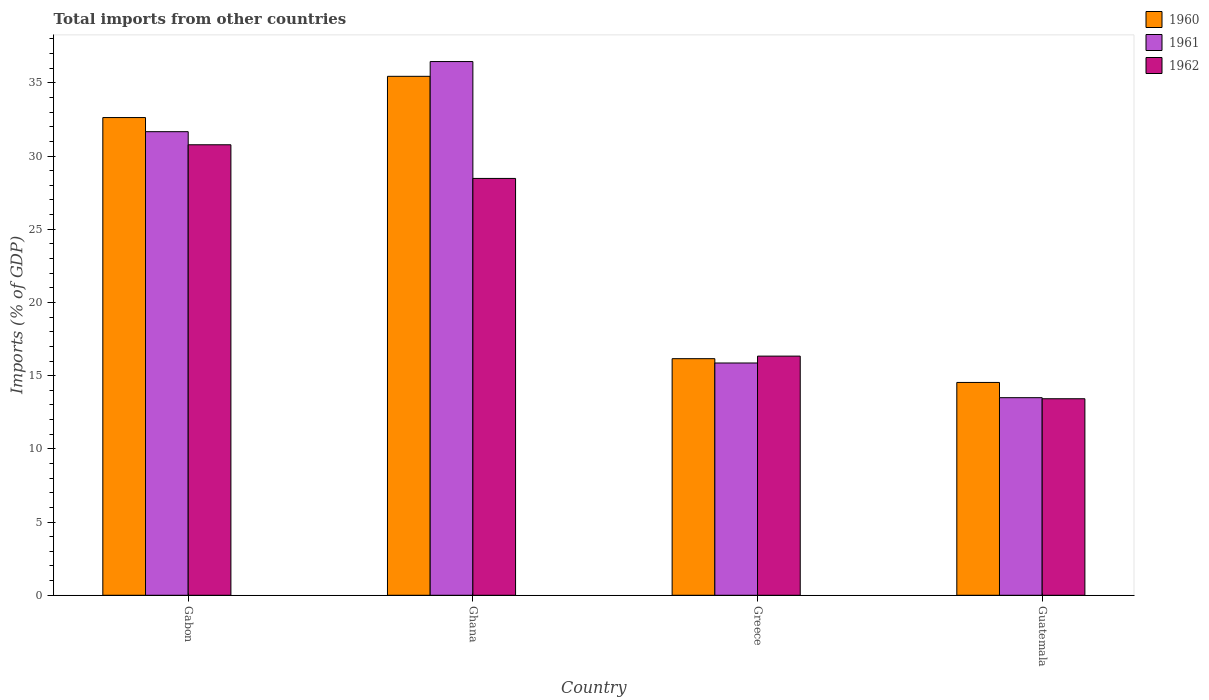How many different coloured bars are there?
Keep it short and to the point. 3. How many groups of bars are there?
Offer a terse response. 4. Are the number of bars per tick equal to the number of legend labels?
Provide a short and direct response. Yes. How many bars are there on the 3rd tick from the right?
Give a very brief answer. 3. What is the label of the 3rd group of bars from the left?
Your answer should be compact. Greece. What is the total imports in 1961 in Greece?
Ensure brevity in your answer.  15.86. Across all countries, what is the maximum total imports in 1961?
Provide a short and direct response. 36.45. Across all countries, what is the minimum total imports in 1960?
Your answer should be very brief. 14.54. In which country was the total imports in 1962 minimum?
Offer a very short reply. Guatemala. What is the total total imports in 1962 in the graph?
Give a very brief answer. 89. What is the difference between the total imports in 1961 in Ghana and that in Greece?
Provide a short and direct response. 20.59. What is the difference between the total imports in 1960 in Ghana and the total imports in 1961 in Gabon?
Provide a short and direct response. 3.78. What is the average total imports in 1960 per country?
Give a very brief answer. 24.69. What is the difference between the total imports of/in 1962 and total imports of/in 1960 in Greece?
Provide a succinct answer. 0.18. What is the ratio of the total imports in 1960 in Gabon to that in Greece?
Give a very brief answer. 2.02. Is the total imports in 1962 in Ghana less than that in Greece?
Make the answer very short. No. What is the difference between the highest and the second highest total imports in 1961?
Keep it short and to the point. -20.59. What is the difference between the highest and the lowest total imports in 1960?
Offer a terse response. 20.91. In how many countries, is the total imports in 1960 greater than the average total imports in 1960 taken over all countries?
Offer a very short reply. 2. What does the 2nd bar from the right in Greece represents?
Give a very brief answer. 1961. How many bars are there?
Offer a terse response. 12. How many countries are there in the graph?
Ensure brevity in your answer.  4. Does the graph contain any zero values?
Your response must be concise. No. Where does the legend appear in the graph?
Give a very brief answer. Top right. What is the title of the graph?
Your answer should be very brief. Total imports from other countries. Does "2012" appear as one of the legend labels in the graph?
Offer a very short reply. No. What is the label or title of the Y-axis?
Ensure brevity in your answer.  Imports (% of GDP). What is the Imports (% of GDP) in 1960 in Gabon?
Your answer should be very brief. 32.63. What is the Imports (% of GDP) in 1961 in Gabon?
Offer a very short reply. 31.66. What is the Imports (% of GDP) of 1962 in Gabon?
Offer a very short reply. 30.77. What is the Imports (% of GDP) in 1960 in Ghana?
Ensure brevity in your answer.  35.44. What is the Imports (% of GDP) in 1961 in Ghana?
Ensure brevity in your answer.  36.45. What is the Imports (% of GDP) in 1962 in Ghana?
Give a very brief answer. 28.47. What is the Imports (% of GDP) in 1960 in Greece?
Give a very brief answer. 16.16. What is the Imports (% of GDP) of 1961 in Greece?
Provide a short and direct response. 15.86. What is the Imports (% of GDP) in 1962 in Greece?
Your answer should be very brief. 16.33. What is the Imports (% of GDP) in 1960 in Guatemala?
Your response must be concise. 14.54. What is the Imports (% of GDP) of 1961 in Guatemala?
Your response must be concise. 13.49. What is the Imports (% of GDP) in 1962 in Guatemala?
Offer a terse response. 13.42. Across all countries, what is the maximum Imports (% of GDP) of 1960?
Your response must be concise. 35.44. Across all countries, what is the maximum Imports (% of GDP) in 1961?
Offer a terse response. 36.45. Across all countries, what is the maximum Imports (% of GDP) in 1962?
Keep it short and to the point. 30.77. Across all countries, what is the minimum Imports (% of GDP) of 1960?
Your response must be concise. 14.54. Across all countries, what is the minimum Imports (% of GDP) of 1961?
Offer a very short reply. 13.49. Across all countries, what is the minimum Imports (% of GDP) in 1962?
Provide a succinct answer. 13.42. What is the total Imports (% of GDP) in 1960 in the graph?
Your answer should be compact. 98.77. What is the total Imports (% of GDP) of 1961 in the graph?
Provide a short and direct response. 97.47. What is the total Imports (% of GDP) in 1962 in the graph?
Offer a terse response. 89. What is the difference between the Imports (% of GDP) in 1960 in Gabon and that in Ghana?
Your answer should be compact. -2.82. What is the difference between the Imports (% of GDP) in 1961 in Gabon and that in Ghana?
Your answer should be very brief. -4.79. What is the difference between the Imports (% of GDP) of 1962 in Gabon and that in Ghana?
Ensure brevity in your answer.  2.3. What is the difference between the Imports (% of GDP) in 1960 in Gabon and that in Greece?
Offer a very short reply. 16.47. What is the difference between the Imports (% of GDP) in 1961 in Gabon and that in Greece?
Offer a terse response. 15.8. What is the difference between the Imports (% of GDP) in 1962 in Gabon and that in Greece?
Offer a very short reply. 14.43. What is the difference between the Imports (% of GDP) of 1960 in Gabon and that in Guatemala?
Make the answer very short. 18.09. What is the difference between the Imports (% of GDP) of 1961 in Gabon and that in Guatemala?
Give a very brief answer. 18.17. What is the difference between the Imports (% of GDP) of 1962 in Gabon and that in Guatemala?
Provide a succinct answer. 17.35. What is the difference between the Imports (% of GDP) in 1960 in Ghana and that in Greece?
Offer a very short reply. 19.28. What is the difference between the Imports (% of GDP) in 1961 in Ghana and that in Greece?
Your response must be concise. 20.59. What is the difference between the Imports (% of GDP) in 1962 in Ghana and that in Greece?
Keep it short and to the point. 12.14. What is the difference between the Imports (% of GDP) of 1960 in Ghana and that in Guatemala?
Ensure brevity in your answer.  20.91. What is the difference between the Imports (% of GDP) of 1961 in Ghana and that in Guatemala?
Ensure brevity in your answer.  22.96. What is the difference between the Imports (% of GDP) of 1962 in Ghana and that in Guatemala?
Your answer should be compact. 15.05. What is the difference between the Imports (% of GDP) in 1960 in Greece and that in Guatemala?
Make the answer very short. 1.62. What is the difference between the Imports (% of GDP) of 1961 in Greece and that in Guatemala?
Make the answer very short. 2.37. What is the difference between the Imports (% of GDP) of 1962 in Greece and that in Guatemala?
Your response must be concise. 2.91. What is the difference between the Imports (% of GDP) in 1960 in Gabon and the Imports (% of GDP) in 1961 in Ghana?
Your answer should be compact. -3.82. What is the difference between the Imports (% of GDP) in 1960 in Gabon and the Imports (% of GDP) in 1962 in Ghana?
Keep it short and to the point. 4.16. What is the difference between the Imports (% of GDP) in 1961 in Gabon and the Imports (% of GDP) in 1962 in Ghana?
Offer a terse response. 3.19. What is the difference between the Imports (% of GDP) in 1960 in Gabon and the Imports (% of GDP) in 1961 in Greece?
Make the answer very short. 16.76. What is the difference between the Imports (% of GDP) of 1960 in Gabon and the Imports (% of GDP) of 1962 in Greece?
Your answer should be compact. 16.29. What is the difference between the Imports (% of GDP) in 1961 in Gabon and the Imports (% of GDP) in 1962 in Greece?
Give a very brief answer. 15.33. What is the difference between the Imports (% of GDP) in 1960 in Gabon and the Imports (% of GDP) in 1961 in Guatemala?
Ensure brevity in your answer.  19.13. What is the difference between the Imports (% of GDP) of 1960 in Gabon and the Imports (% of GDP) of 1962 in Guatemala?
Ensure brevity in your answer.  19.2. What is the difference between the Imports (% of GDP) in 1961 in Gabon and the Imports (% of GDP) in 1962 in Guatemala?
Provide a succinct answer. 18.24. What is the difference between the Imports (% of GDP) in 1960 in Ghana and the Imports (% of GDP) in 1961 in Greece?
Give a very brief answer. 19.58. What is the difference between the Imports (% of GDP) in 1960 in Ghana and the Imports (% of GDP) in 1962 in Greece?
Offer a very short reply. 19.11. What is the difference between the Imports (% of GDP) of 1961 in Ghana and the Imports (% of GDP) of 1962 in Greece?
Your response must be concise. 20.12. What is the difference between the Imports (% of GDP) of 1960 in Ghana and the Imports (% of GDP) of 1961 in Guatemala?
Keep it short and to the point. 21.95. What is the difference between the Imports (% of GDP) of 1960 in Ghana and the Imports (% of GDP) of 1962 in Guatemala?
Offer a terse response. 22.02. What is the difference between the Imports (% of GDP) in 1961 in Ghana and the Imports (% of GDP) in 1962 in Guatemala?
Ensure brevity in your answer.  23.03. What is the difference between the Imports (% of GDP) of 1960 in Greece and the Imports (% of GDP) of 1961 in Guatemala?
Make the answer very short. 2.66. What is the difference between the Imports (% of GDP) in 1960 in Greece and the Imports (% of GDP) in 1962 in Guatemala?
Ensure brevity in your answer.  2.74. What is the difference between the Imports (% of GDP) of 1961 in Greece and the Imports (% of GDP) of 1962 in Guatemala?
Make the answer very short. 2.44. What is the average Imports (% of GDP) of 1960 per country?
Give a very brief answer. 24.69. What is the average Imports (% of GDP) of 1961 per country?
Provide a short and direct response. 24.37. What is the average Imports (% of GDP) of 1962 per country?
Make the answer very short. 22.25. What is the difference between the Imports (% of GDP) in 1960 and Imports (% of GDP) in 1961 in Gabon?
Provide a short and direct response. 0.96. What is the difference between the Imports (% of GDP) of 1960 and Imports (% of GDP) of 1962 in Gabon?
Provide a short and direct response. 1.86. What is the difference between the Imports (% of GDP) in 1961 and Imports (% of GDP) in 1962 in Gabon?
Provide a succinct answer. 0.89. What is the difference between the Imports (% of GDP) in 1960 and Imports (% of GDP) in 1961 in Ghana?
Provide a succinct answer. -1.01. What is the difference between the Imports (% of GDP) in 1960 and Imports (% of GDP) in 1962 in Ghana?
Provide a succinct answer. 6.97. What is the difference between the Imports (% of GDP) in 1961 and Imports (% of GDP) in 1962 in Ghana?
Offer a very short reply. 7.98. What is the difference between the Imports (% of GDP) of 1960 and Imports (% of GDP) of 1961 in Greece?
Give a very brief answer. 0.29. What is the difference between the Imports (% of GDP) in 1960 and Imports (% of GDP) in 1962 in Greece?
Give a very brief answer. -0.18. What is the difference between the Imports (% of GDP) of 1961 and Imports (% of GDP) of 1962 in Greece?
Provide a succinct answer. -0.47. What is the difference between the Imports (% of GDP) in 1960 and Imports (% of GDP) in 1961 in Guatemala?
Ensure brevity in your answer.  1.04. What is the difference between the Imports (% of GDP) of 1960 and Imports (% of GDP) of 1962 in Guatemala?
Make the answer very short. 1.11. What is the difference between the Imports (% of GDP) of 1961 and Imports (% of GDP) of 1962 in Guatemala?
Give a very brief answer. 0.07. What is the ratio of the Imports (% of GDP) in 1960 in Gabon to that in Ghana?
Ensure brevity in your answer.  0.92. What is the ratio of the Imports (% of GDP) of 1961 in Gabon to that in Ghana?
Keep it short and to the point. 0.87. What is the ratio of the Imports (% of GDP) of 1962 in Gabon to that in Ghana?
Give a very brief answer. 1.08. What is the ratio of the Imports (% of GDP) in 1960 in Gabon to that in Greece?
Offer a terse response. 2.02. What is the ratio of the Imports (% of GDP) of 1961 in Gabon to that in Greece?
Provide a short and direct response. 2. What is the ratio of the Imports (% of GDP) in 1962 in Gabon to that in Greece?
Your response must be concise. 1.88. What is the ratio of the Imports (% of GDP) of 1960 in Gabon to that in Guatemala?
Your response must be concise. 2.24. What is the ratio of the Imports (% of GDP) in 1961 in Gabon to that in Guatemala?
Your answer should be compact. 2.35. What is the ratio of the Imports (% of GDP) of 1962 in Gabon to that in Guatemala?
Make the answer very short. 2.29. What is the ratio of the Imports (% of GDP) in 1960 in Ghana to that in Greece?
Offer a terse response. 2.19. What is the ratio of the Imports (% of GDP) in 1961 in Ghana to that in Greece?
Make the answer very short. 2.3. What is the ratio of the Imports (% of GDP) in 1962 in Ghana to that in Greece?
Give a very brief answer. 1.74. What is the ratio of the Imports (% of GDP) in 1960 in Ghana to that in Guatemala?
Your answer should be very brief. 2.44. What is the ratio of the Imports (% of GDP) of 1961 in Ghana to that in Guatemala?
Give a very brief answer. 2.7. What is the ratio of the Imports (% of GDP) in 1962 in Ghana to that in Guatemala?
Your answer should be compact. 2.12. What is the ratio of the Imports (% of GDP) of 1960 in Greece to that in Guatemala?
Your answer should be very brief. 1.11. What is the ratio of the Imports (% of GDP) in 1961 in Greece to that in Guatemala?
Provide a succinct answer. 1.18. What is the ratio of the Imports (% of GDP) of 1962 in Greece to that in Guatemala?
Offer a terse response. 1.22. What is the difference between the highest and the second highest Imports (% of GDP) of 1960?
Your response must be concise. 2.82. What is the difference between the highest and the second highest Imports (% of GDP) in 1961?
Provide a succinct answer. 4.79. What is the difference between the highest and the second highest Imports (% of GDP) in 1962?
Your answer should be compact. 2.3. What is the difference between the highest and the lowest Imports (% of GDP) in 1960?
Make the answer very short. 20.91. What is the difference between the highest and the lowest Imports (% of GDP) in 1961?
Give a very brief answer. 22.96. What is the difference between the highest and the lowest Imports (% of GDP) in 1962?
Your response must be concise. 17.35. 